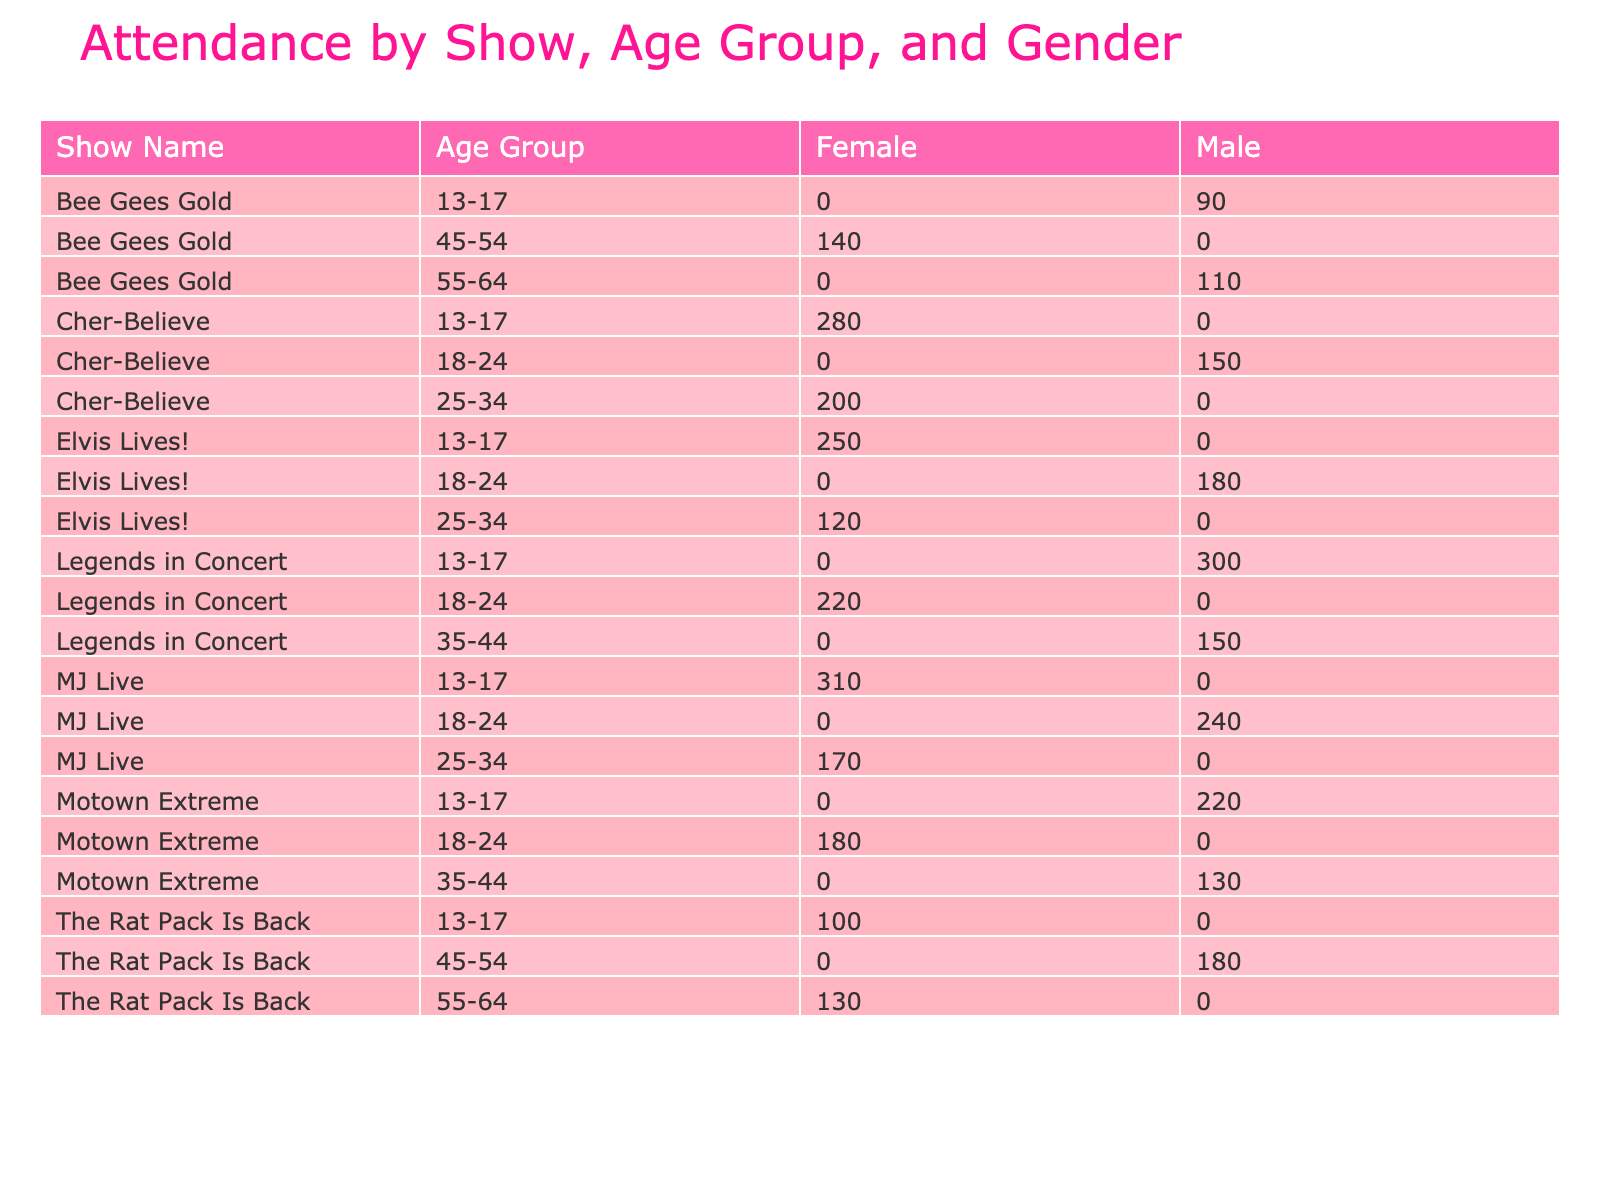What's the total attendance for "MJ Live"? From the table, we can see the attendance values for "MJ Live" across different age groups. For 13-17 age group, the attendance is 310, for 18-24 it's 240, and for 25-34, it's 170. Summing them up gives: 310 + 240 + 170 = 720.
Answer: 720 Which show has the highest attendance from the 13-17 age group? Looking at the attendance values for the 13-17 age group across all shows, "MJ Live" has 310, "Legends in Concert" has 300, "Cher-Believe" has 280, and "Motown Extreme" has 220. The highest attendance is 310 for "MJ Live".
Answer: MJ Live Is there a female audience present for "Bee Gees Gold"? Checking the table, "Bee Gees Gold" has attendance values listed under both female and male categories. For the female category, the attendance is 140, indicating that there is indeed female audience presence.
Answer: Yes What is the total attendance for shows featuring Michael Jackson? The shows featuring Michael Jackson are "Legends in Concert" and "MJ Live". For "Legends in Concert", the attendance values relevant are: 300 (13-17 Male) and 150 (35-44 Male), summing to 450. For "MJ Live", we already calculated the total attendance as 720. The total is: 450 + 720 = 1170.
Answer: 1170 How many male attendees are there in “The Rat Pack Is Back”? The male attendance values for "The Rat Pack Is Back" are 180 (age 45-54) and 0 for other age groups since no males are listed for age groups 13-17 and 55-64. Therefore, total male attendance for the show is 180 + 0 + 0 = 180.
Answer: 180 Among the shows listed, which has the highest attendance in the 18-24 age group and what is that attendance? In the 18-24 age group, we examine the attendance: "Elvis Lives!" has 180, "Legends in Concert" has 220, "Cher-Believe" has 150, "Motown Extreme" has 180, and "MJ Live" has 240. The highest attendance in this age group is 240 for "MJ Live".
Answer: 240 How many females attended all shows combined? To find the total number of female attendees across all shows, we sum up the female attendance values. Adding them together gives: 250 (Elvis Lives!) + 120 (Elvis Lives!) + 100 (The Rat Pack Is Back) + 280 (Cher-Believe) + 180 (Motown Extreme) + 170 (MJ Live) + 140 (Bee Gees Gold) = 1240.
Answer: 1240 